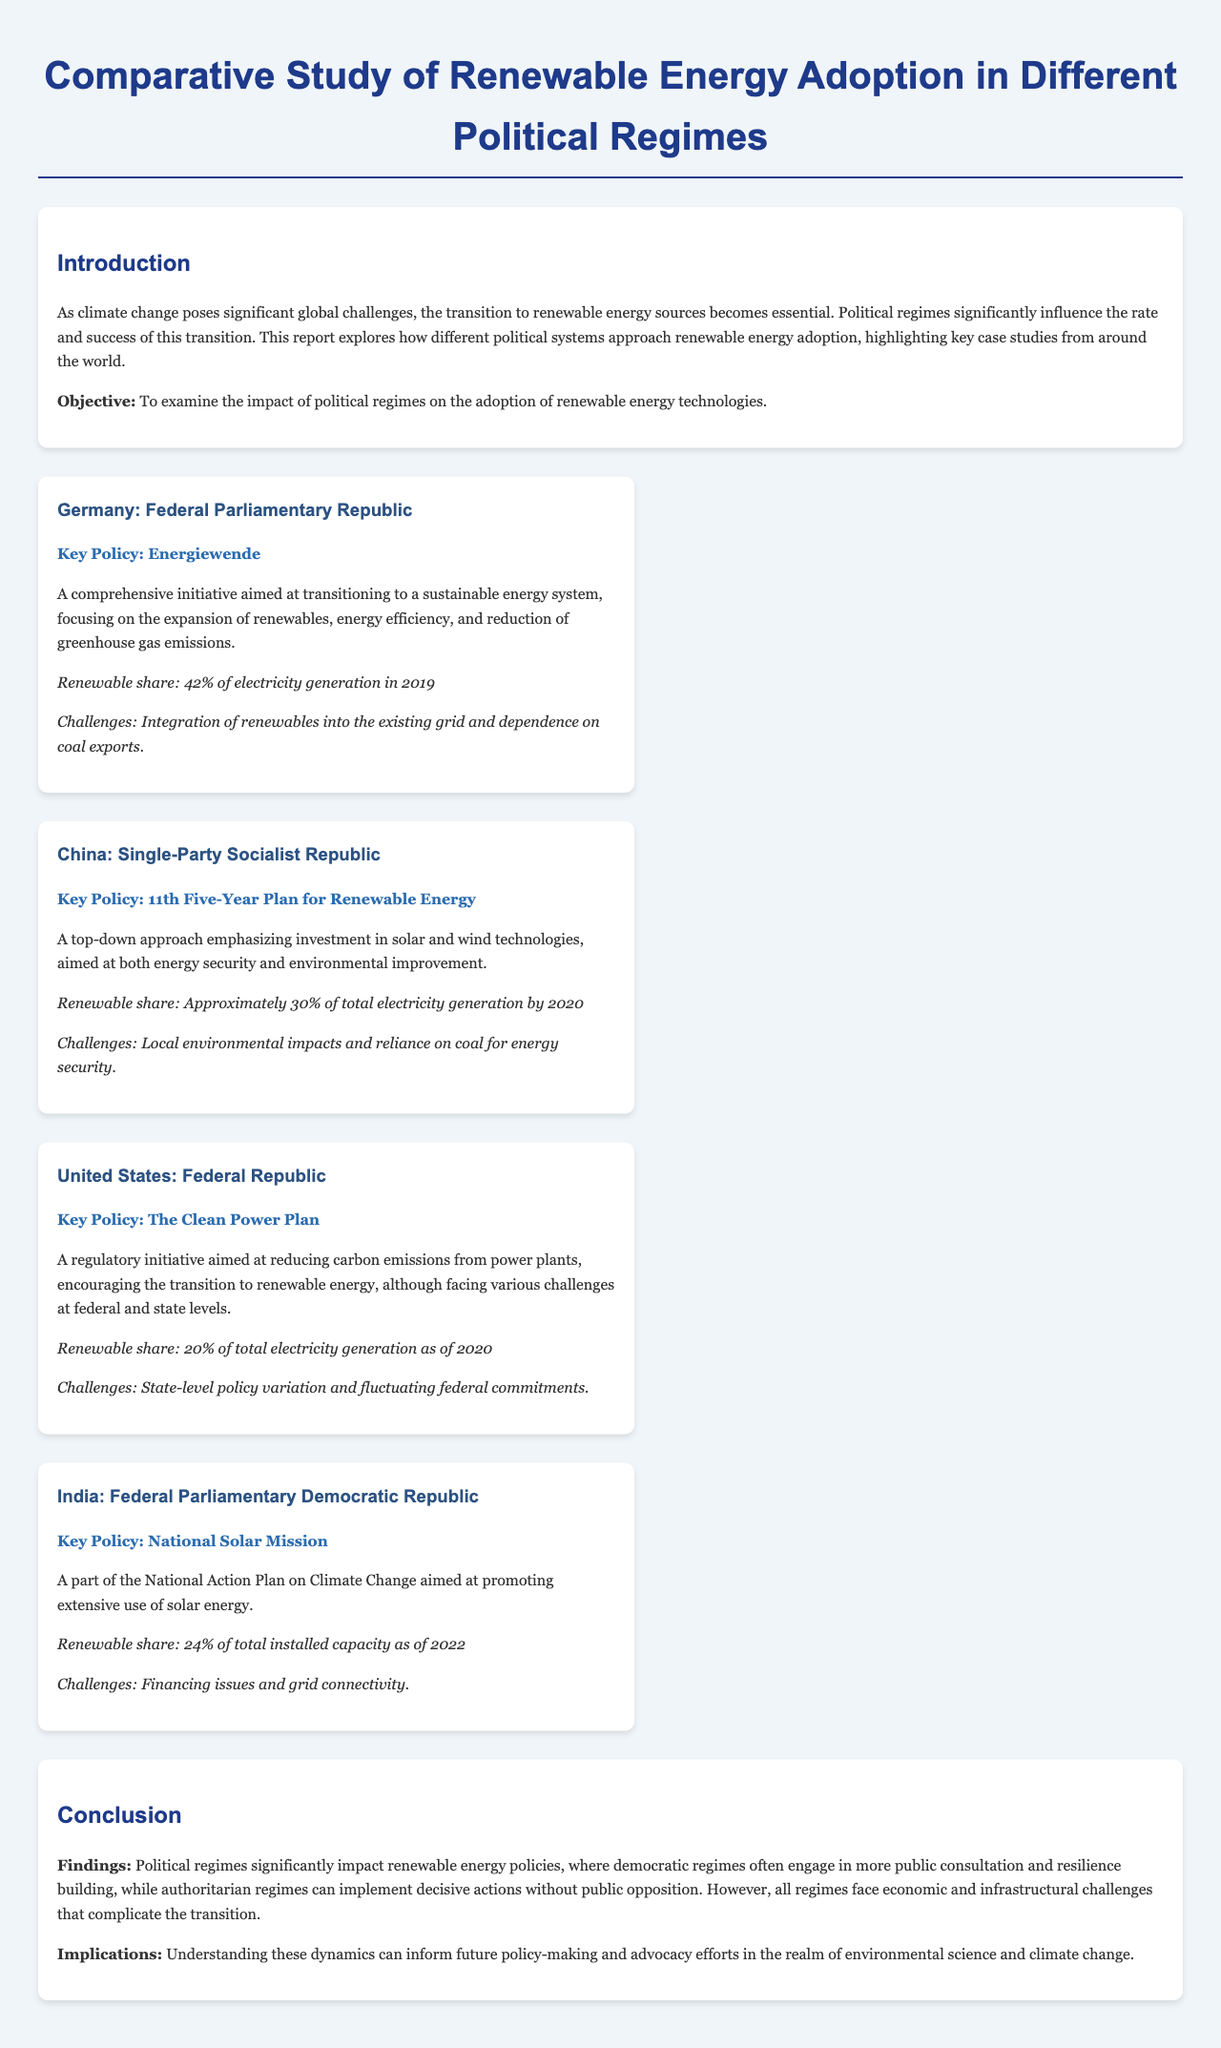What is the key policy of Germany? The key policy for Germany is the 'Energiewende', which aims at transitioning to a sustainable energy system.
Answer: Energiewende What percentage of electricity generation in Germany was from renewables in 2019? In 2019, the renewable share of electricity generation in Germany was 42%.
Answer: 42% What was China's renewable share of total electricity generation by 2020? By 2020, China's renewable share of total electricity generation was approximately 30%.
Answer: 30% What challenges does the United States face in renewable energy adoption? The United States faces state-level policy variation and fluctuating federal commitments.
Answer: State-level policy variation and fluctuating federal commitments Which country has a key policy called the National Solar Mission? India has a key policy called the National Solar Mission, aimed at promoting solar energy use.
Answer: India In terms of political regimes, which type tends to engage more in public consultation for renewable energy policies? Democratic regimes often engage in more public consultation regarding renewable energy policies.
Answer: Democratic regimes What is the renewable share of India's total installed capacity as of 2022? As of 2022, the renewable share of India's total installed capacity was 24%.
Answer: 24% What is the main implication of the findings regarding political regimes? The findings suggest that understanding the dynamics of political regimes can inform future policy-making efforts.
Answer: Inform future policy-making efforts 